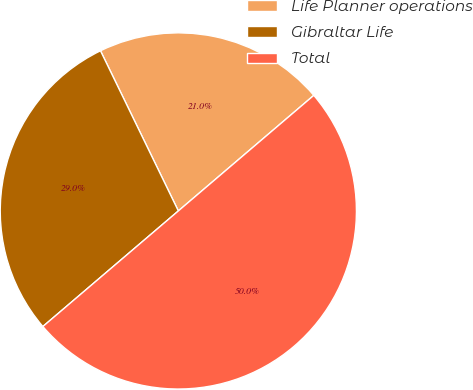Convert chart to OTSL. <chart><loc_0><loc_0><loc_500><loc_500><pie_chart><fcel>Life Planner operations<fcel>Gibraltar Life<fcel>Total<nl><fcel>20.96%<fcel>29.04%<fcel>50.0%<nl></chart> 